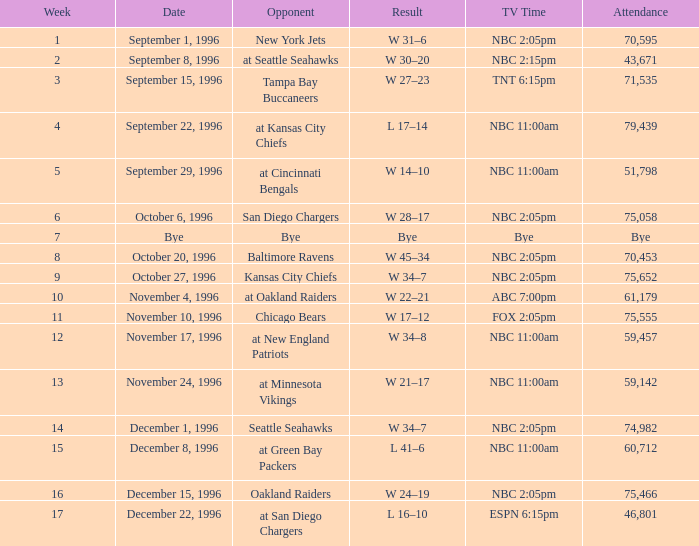WHAT IS THE TV TIME WOTH A WEEK BIGGER THAN 15, WITH THE OAKLAND RAIDERS AS OPPONENT? NBC 2:05pm. 